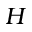Convert formula to latex. <formula><loc_0><loc_0><loc_500><loc_500>H</formula> 